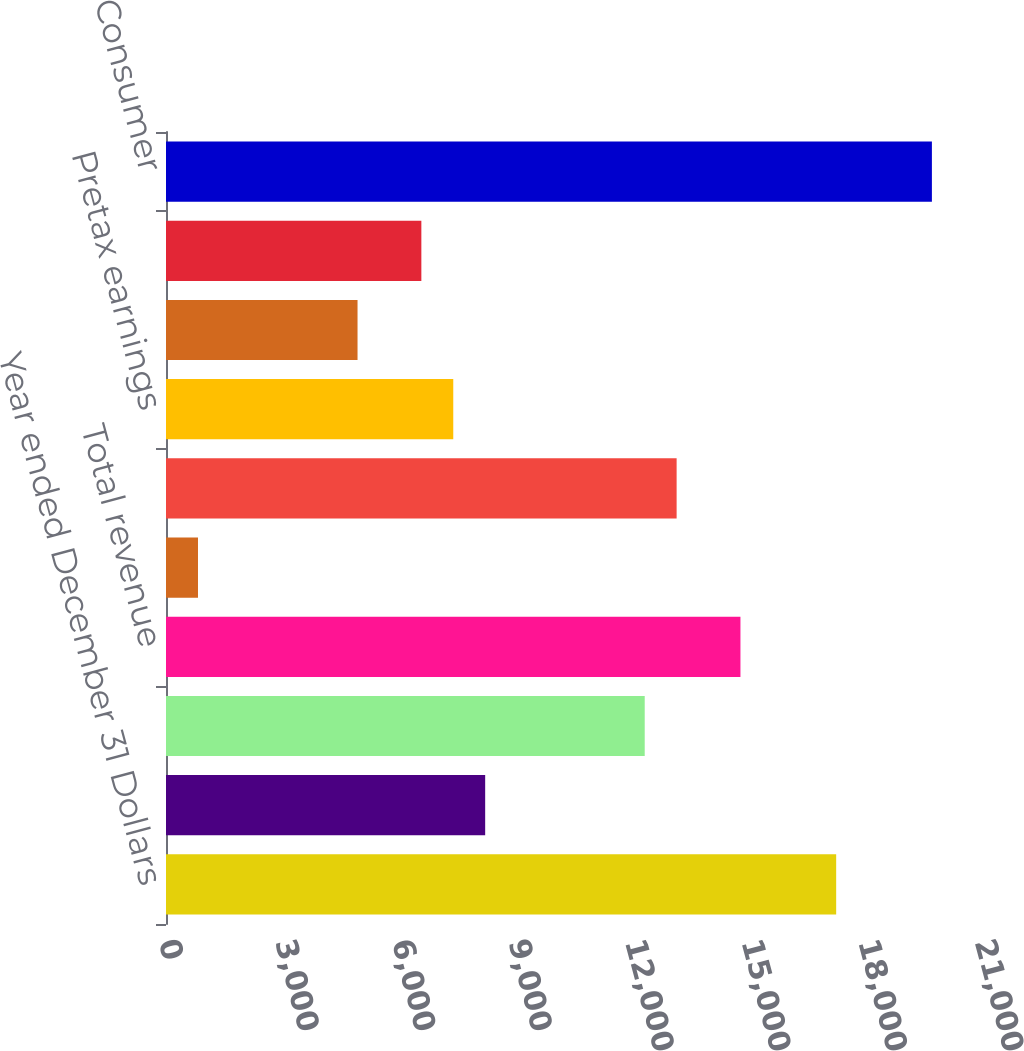Convert chart to OTSL. <chart><loc_0><loc_0><loc_500><loc_500><bar_chart><fcel>Year ended December 31 Dollars<fcel>Net interest income<fcel>Noninterest income<fcel>Total revenue<fcel>Provision for credit losses<fcel>Noninterest expense<fcel>Pretax earnings<fcel>Income taxes<fcel>Earnings<fcel>Consumer<nl><fcel>17247.1<fcel>8214<fcel>12320<fcel>14783.5<fcel>823.29<fcel>13141.1<fcel>7392.81<fcel>4929.24<fcel>6571.62<fcel>19710.7<nl></chart> 